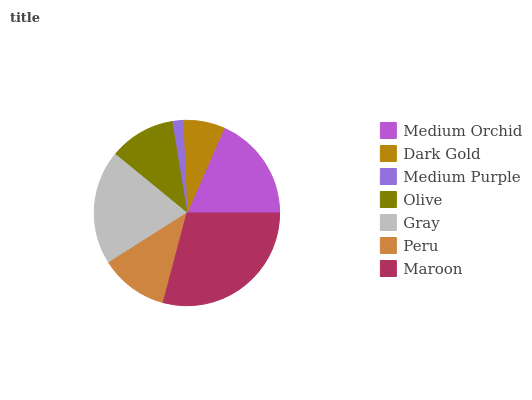Is Medium Purple the minimum?
Answer yes or no. Yes. Is Maroon the maximum?
Answer yes or no. Yes. Is Dark Gold the minimum?
Answer yes or no. No. Is Dark Gold the maximum?
Answer yes or no. No. Is Medium Orchid greater than Dark Gold?
Answer yes or no. Yes. Is Dark Gold less than Medium Orchid?
Answer yes or no. Yes. Is Dark Gold greater than Medium Orchid?
Answer yes or no. No. Is Medium Orchid less than Dark Gold?
Answer yes or no. No. Is Peru the high median?
Answer yes or no. Yes. Is Peru the low median?
Answer yes or no. Yes. Is Gray the high median?
Answer yes or no. No. Is Maroon the low median?
Answer yes or no. No. 